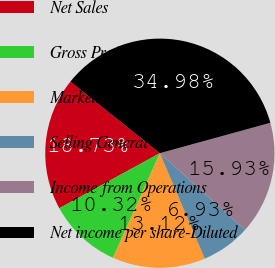<chart> <loc_0><loc_0><loc_500><loc_500><pie_chart><fcel>Net Sales<fcel>Gross Profit<fcel>Marketing Expenses<fcel>Selling General &<fcel>Income from Operations<fcel>Net income per share-Diluted<nl><fcel>18.73%<fcel>10.32%<fcel>13.12%<fcel>6.93%<fcel>15.93%<fcel>34.98%<nl></chart> 